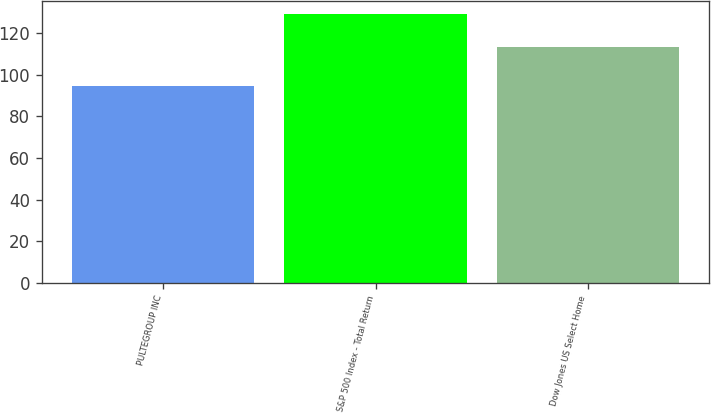Convert chart to OTSL. <chart><loc_0><loc_0><loc_500><loc_500><bar_chart><fcel>PULTEGROUP INC<fcel>S&P 500 Index - Total Return<fcel>Dow Jones US Select Home<nl><fcel>94.63<fcel>129.05<fcel>113.34<nl></chart> 